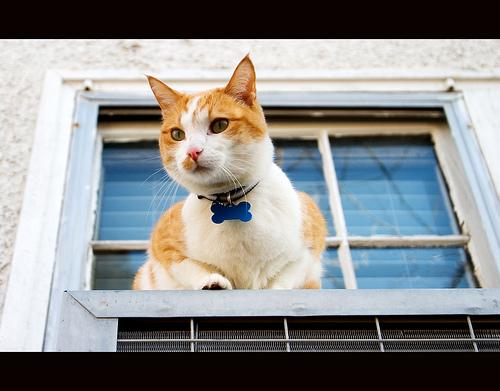Mention the key object that the cat is sitting on and its color. The cat is perched elegantly on a silver air vent, which is made of metal and appears to be an AC unit. Analyze the cat's position in the image and where it's situated in relation to any windows. The captivating cat sits on an AC unit right outside a clear glass window, giving the impression of an indoor-outdoor setting. List down the window features. The window has a white frame, clear glass, mesh, blinds inside, and a gray stucco on the outside wall, with tree limbs reflecting on its pane. Count the number of visible distinct ears, eyes, and mouth features of the cat in the image. The image displays two pointy ears, two green eyes, and one petite mouth of the enchanting cat. Identify the attributes of the cat's face, including its eyes, nose, and whiskers. The cat's face boasts alluring green eyes, a small pink nose, and delicate white whiskers, reflecting a perfect blend of charm and grace. In a poetic manner, describe the appearance of the cat in the image. A graceful feline, dressed in hues of orange and white, with green eyes that mysterious twinkle, and whiskers dancing like silk threads. On her collar, a blue tag of ownership hangs. How would you describe the cat's overall appearance based on its fur and eyes? The cat appears rather mesmerizing, with its furry orange and white coat that tickles the senses and hypnotic green eyes that draw you in deeply. Considering the environment and the subject, what emotion do you associate with this image? The heartwarming sight of the inquisitive cat sitting by the window brings forth a sense of curiosity, tranquility, and contentment. Explain the relationship between the depicted feline and its living environment. The feline sits calmly on an air vent, perusing the world beyond the glass window, which separates its safe abode from the untamed outside. What unique characteristics does this cat have on its collar and what color is the collar? This marvelous cat has a blue tag and a blue bone ornament dangling from its black collar. 